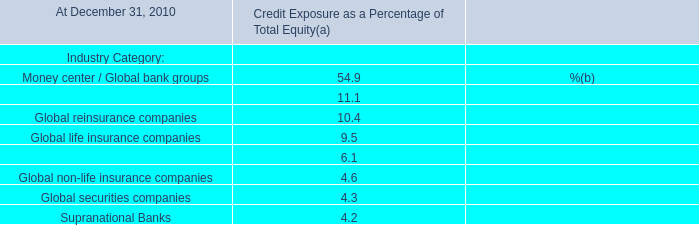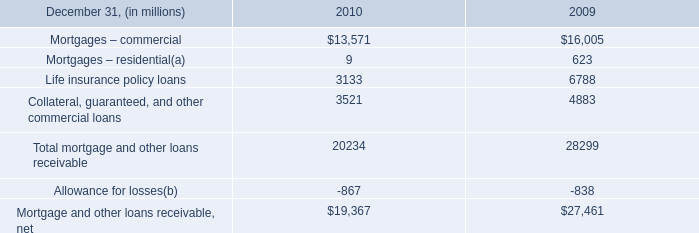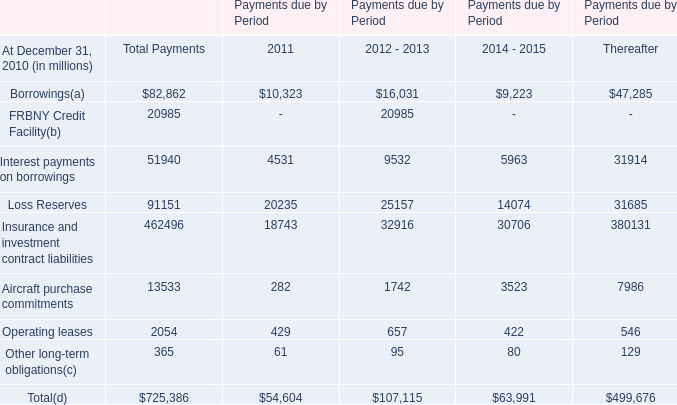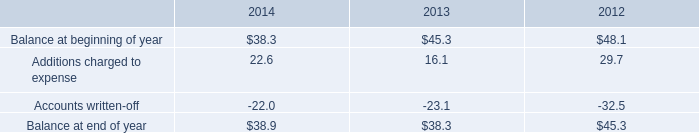what's the total amount of Collateral, guaranteed, and other commercial loans of 2009, and Aircraft purchase commitments of Payments due by Period Thereafter ? 
Computations: (4883.0 + 7986.0)
Answer: 12869.0. 